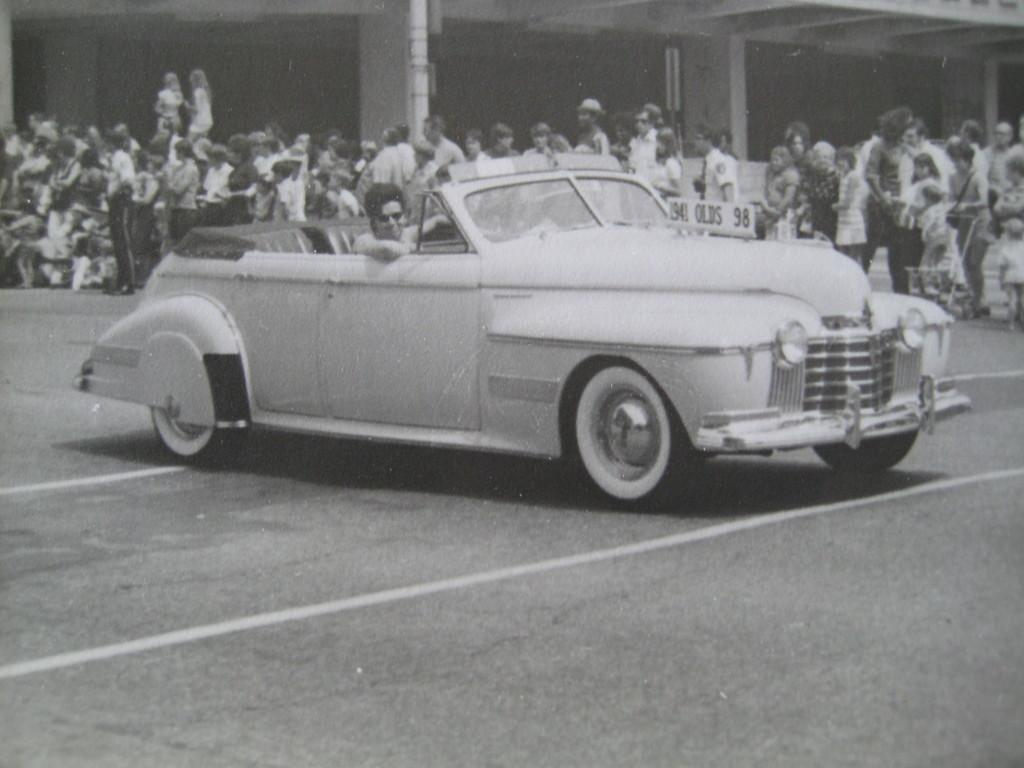What is the person in the image doing? There is a person sitting in a vehicle in the image. What can be seen in the background of the image? There are people standing in the background. What is the color scheme of the image? The image is in black and white. What type of suit is the person wearing in the image? There is no suit visible in the image, as it is in black and white and does not show the person's clothing in detail. 